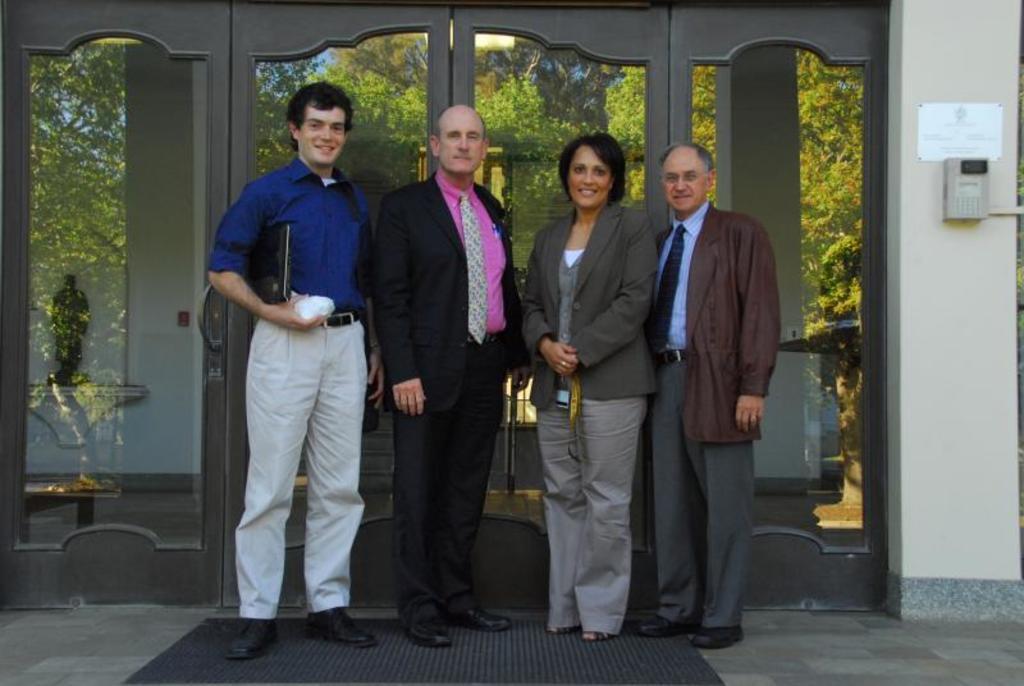In one or two sentences, can you explain what this image depicts? In this image there are a few people standing with a smile on their face, one of them is holding an object and a file, behind them there is a door of a building and there is an object and a board is hanging on the wall. At the bottom of the image there is a mat on the surface. 